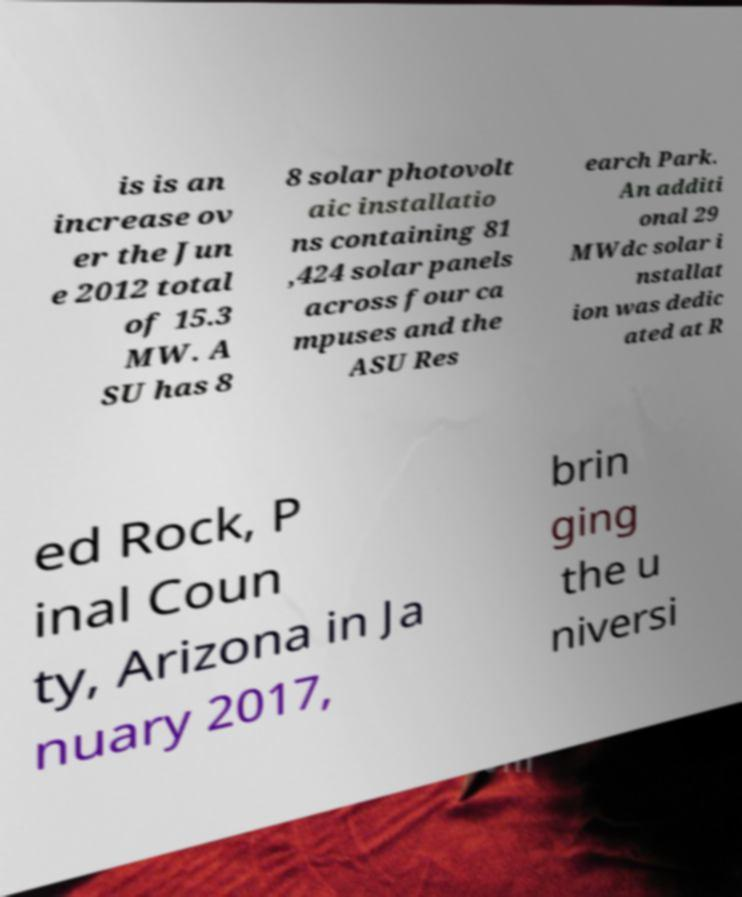Could you extract and type out the text from this image? is is an increase ov er the Jun e 2012 total of 15.3 MW. A SU has 8 8 solar photovolt aic installatio ns containing 81 ,424 solar panels across four ca mpuses and the ASU Res earch Park. An additi onal 29 MWdc solar i nstallat ion was dedic ated at R ed Rock, P inal Coun ty, Arizona in Ja nuary 2017, brin ging the u niversi 